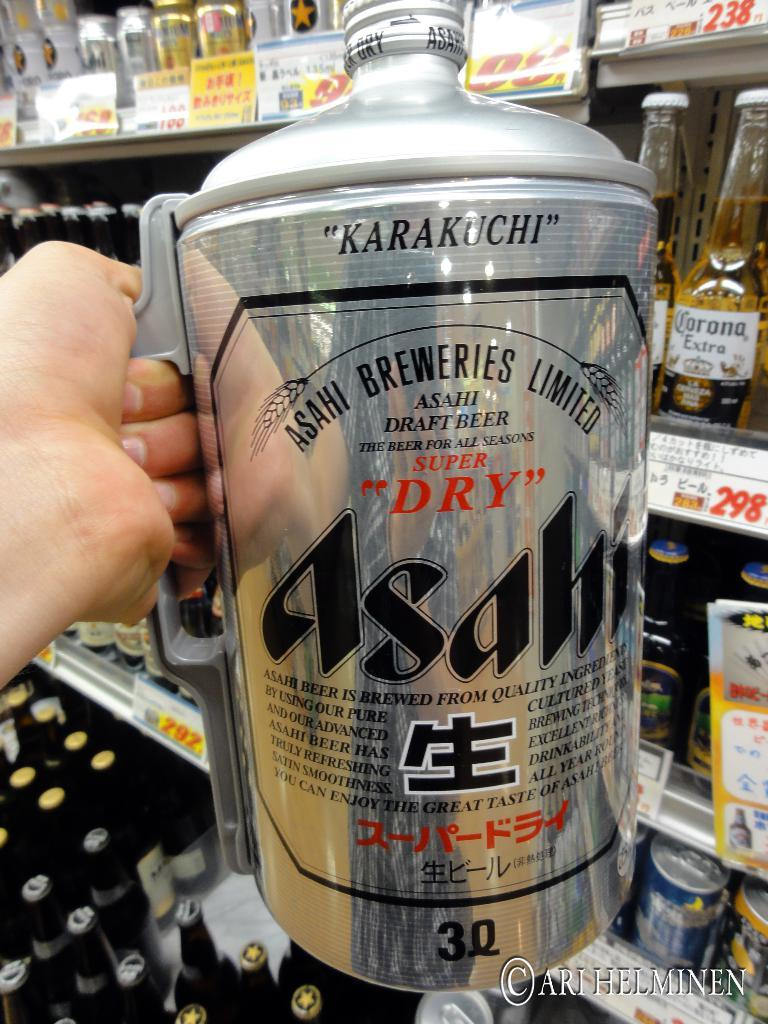<image>
Describe the image concisely. an aluminum can with a handle on it that says 'karakuchi' onit 